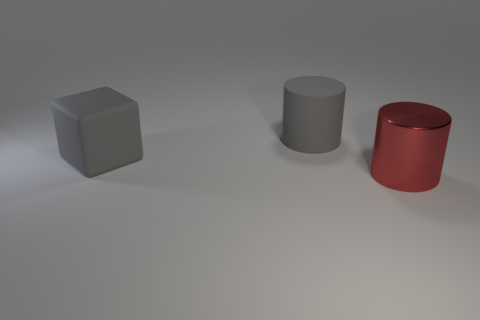Add 3 big gray matte blocks. How many objects exist? 6 Subtract all cubes. How many objects are left? 2 Subtract 0 red spheres. How many objects are left? 3 Subtract all red cylinders. Subtract all big matte blocks. How many objects are left? 1 Add 3 gray matte objects. How many gray matte objects are left? 5 Add 2 cylinders. How many cylinders exist? 4 